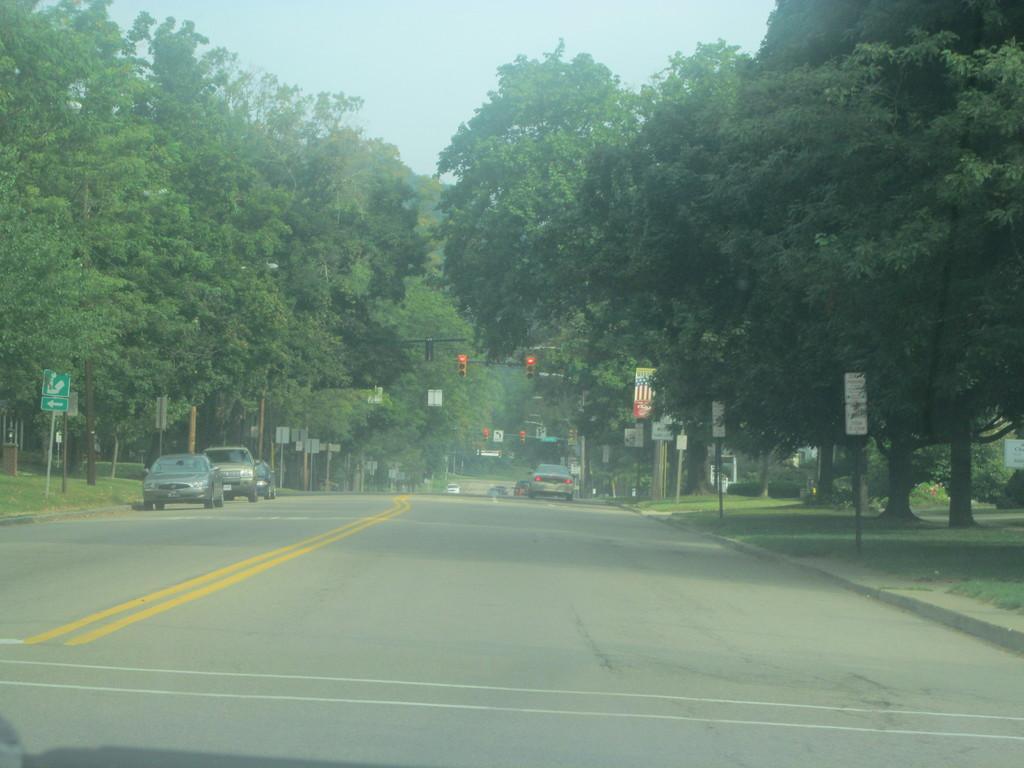How would you summarize this image in a sentence or two? There is a road in the foreground area of the image and there are vehicles, poles, posters, trees and sky in the background area. 